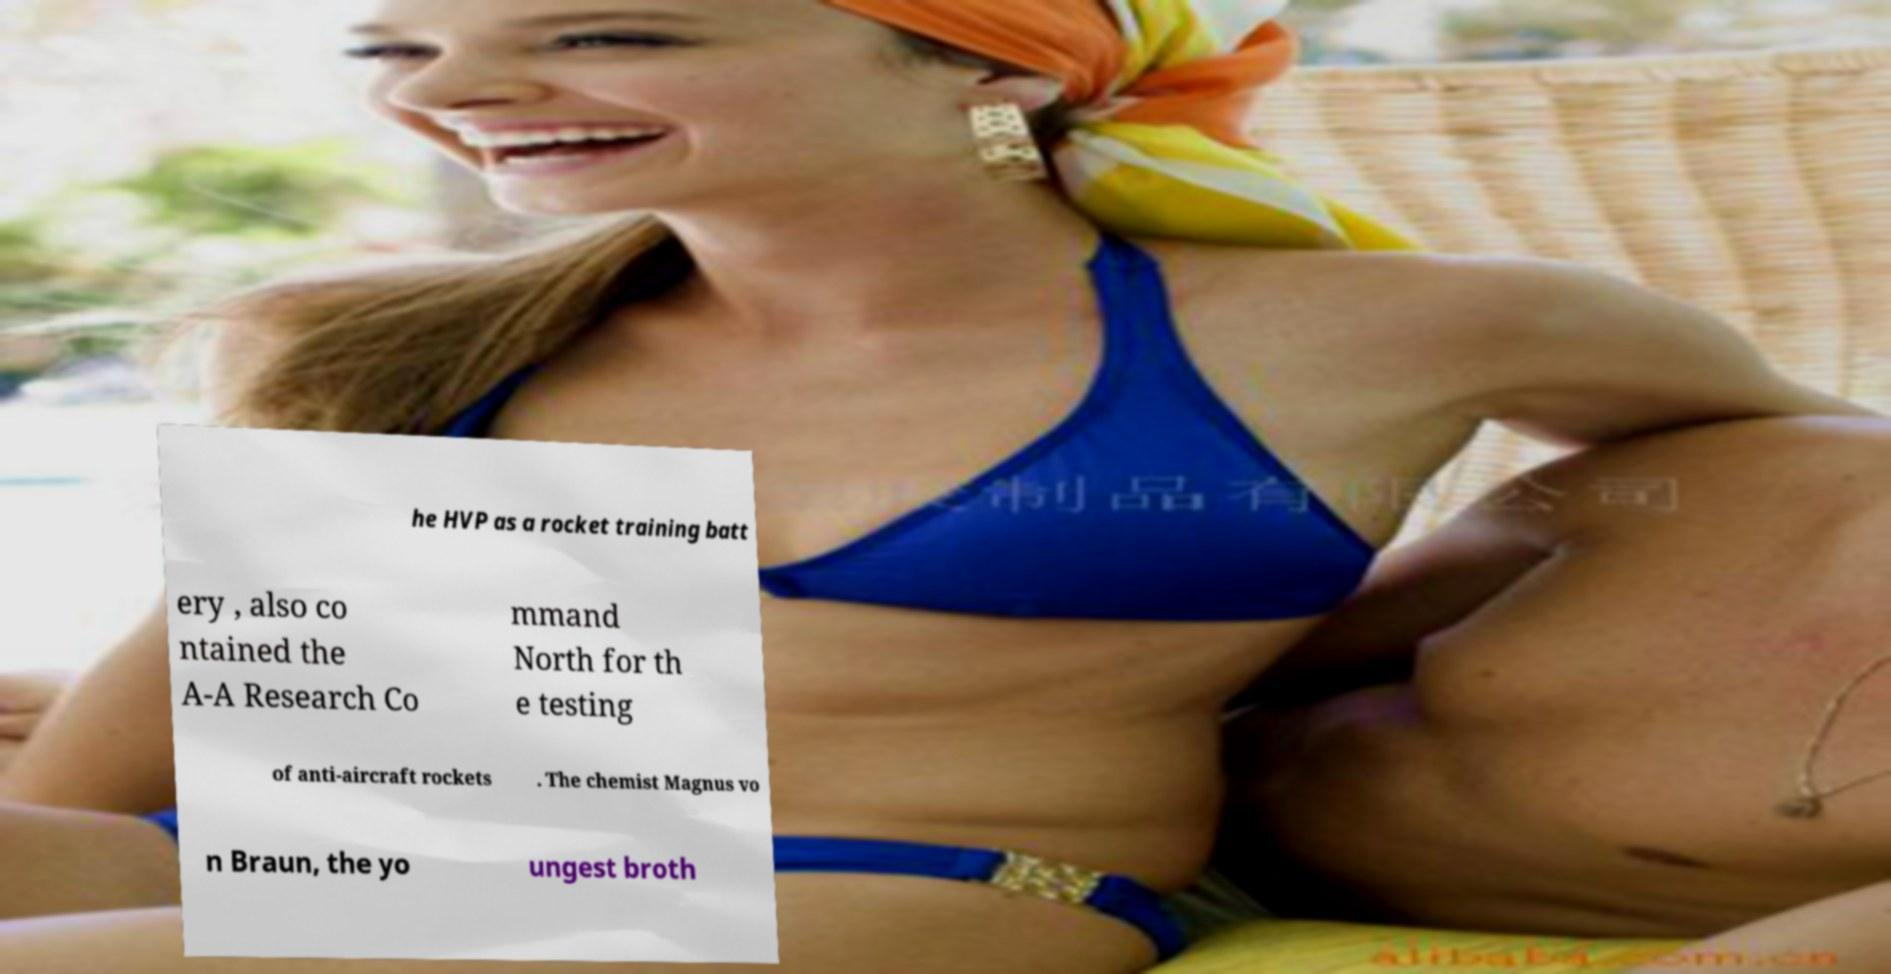Could you extract and type out the text from this image? he HVP as a rocket training batt ery , also co ntained the A-A Research Co mmand North for th e testing of anti-aircraft rockets . The chemist Magnus vo n Braun, the yo ungest broth 